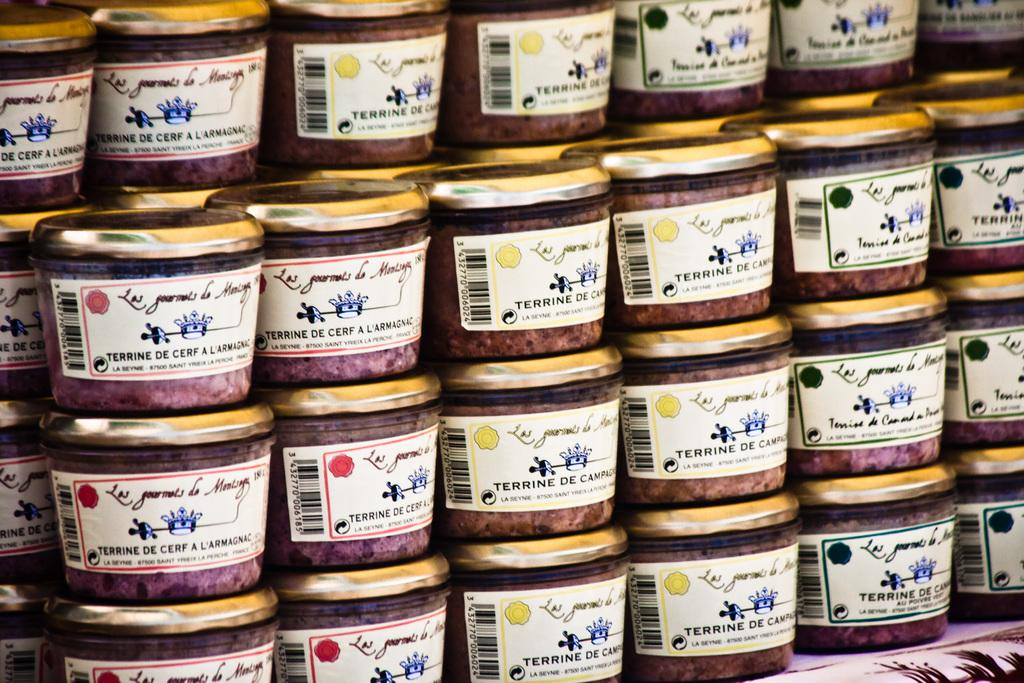What objects are arranged in the image? Containers are arranged in the image. What type of meal is being prepared in the image? There is no indication of a meal being prepared in the image, as it only shows containers arranged in a certain way. 